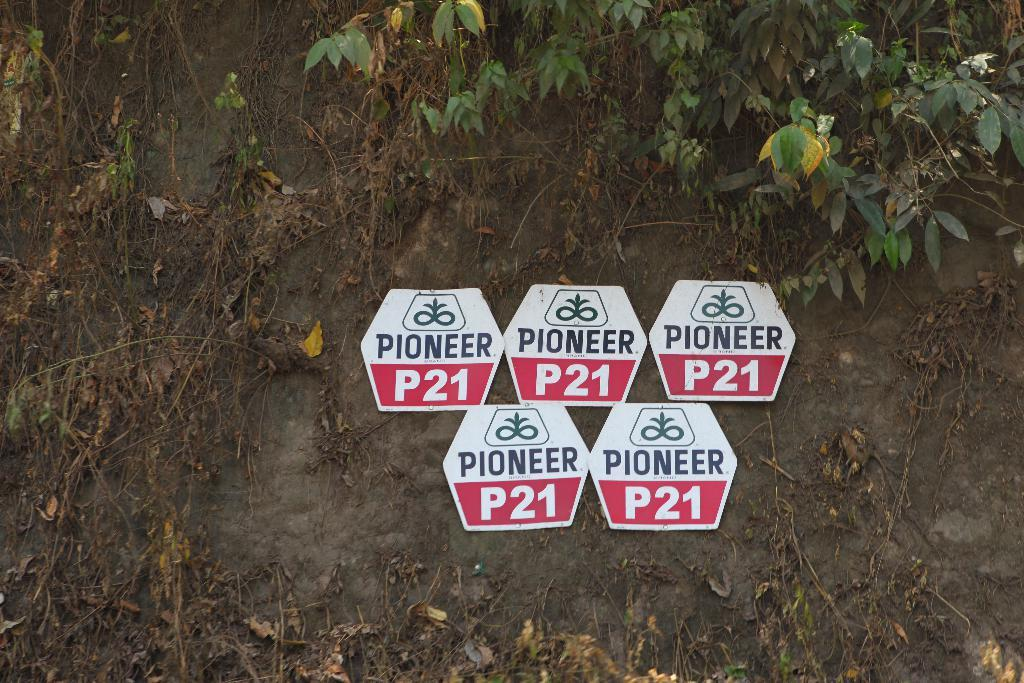What objects are in the image that resemble flat, thin pieces of material? There are boards in the image. What type of living organisms can be seen in the image? Plants are visible in the image. What part of the plants can be seen in the image? Dry leaves and stems are visible in the image. How many cars can be seen driving through the minute in the image? There are no cars or minutes present in the image; it features boards and plants. 